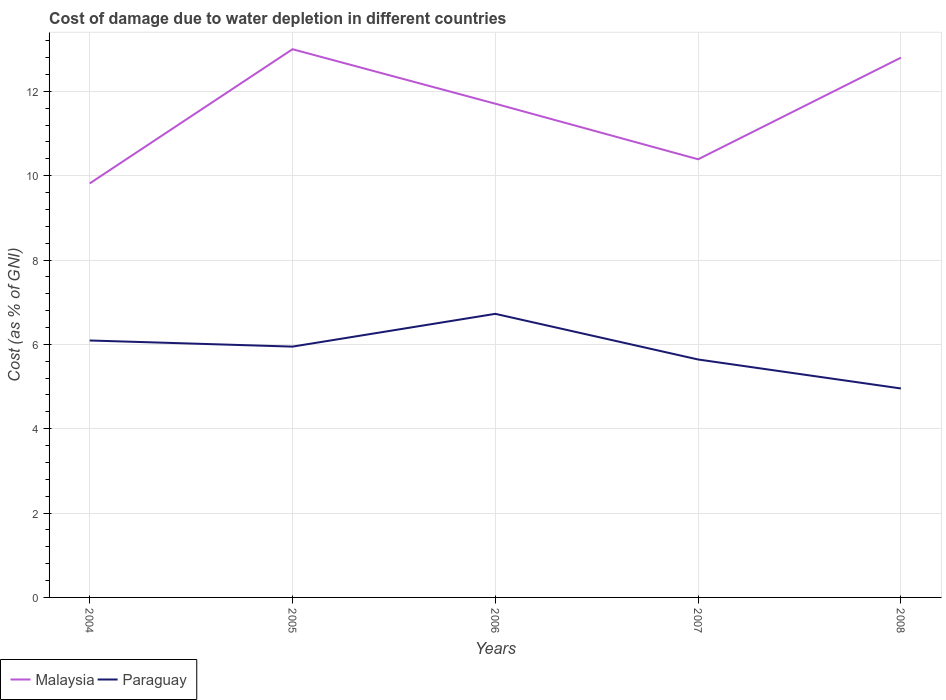Across all years, what is the maximum cost of damage caused due to water depletion in Malaysia?
Your response must be concise. 9.82. In which year was the cost of damage caused due to water depletion in Malaysia maximum?
Offer a terse response. 2004. What is the total cost of damage caused due to water depletion in Malaysia in the graph?
Give a very brief answer. -0.57. What is the difference between the highest and the second highest cost of damage caused due to water depletion in Malaysia?
Provide a succinct answer. 3.18. What is the difference between the highest and the lowest cost of damage caused due to water depletion in Paraguay?
Your answer should be compact. 3. Is the cost of damage caused due to water depletion in Malaysia strictly greater than the cost of damage caused due to water depletion in Paraguay over the years?
Ensure brevity in your answer.  No. How many lines are there?
Offer a very short reply. 2. How many years are there in the graph?
Your response must be concise. 5. What is the difference between two consecutive major ticks on the Y-axis?
Provide a short and direct response. 2. Are the values on the major ticks of Y-axis written in scientific E-notation?
Give a very brief answer. No. Where does the legend appear in the graph?
Keep it short and to the point. Bottom left. How many legend labels are there?
Provide a succinct answer. 2. How are the legend labels stacked?
Keep it short and to the point. Horizontal. What is the title of the graph?
Provide a succinct answer. Cost of damage due to water depletion in different countries. Does "Upper middle income" appear as one of the legend labels in the graph?
Your answer should be very brief. No. What is the label or title of the Y-axis?
Keep it short and to the point. Cost (as % of GNI). What is the Cost (as % of GNI) in Malaysia in 2004?
Offer a very short reply. 9.82. What is the Cost (as % of GNI) of Paraguay in 2004?
Provide a succinct answer. 6.09. What is the Cost (as % of GNI) of Malaysia in 2005?
Your answer should be compact. 13. What is the Cost (as % of GNI) of Paraguay in 2005?
Offer a terse response. 5.95. What is the Cost (as % of GNI) of Malaysia in 2006?
Offer a very short reply. 11.71. What is the Cost (as % of GNI) of Paraguay in 2006?
Provide a short and direct response. 6.72. What is the Cost (as % of GNI) of Malaysia in 2007?
Your answer should be very brief. 10.39. What is the Cost (as % of GNI) in Paraguay in 2007?
Provide a short and direct response. 5.64. What is the Cost (as % of GNI) of Malaysia in 2008?
Your answer should be compact. 12.8. What is the Cost (as % of GNI) in Paraguay in 2008?
Make the answer very short. 4.95. Across all years, what is the maximum Cost (as % of GNI) in Malaysia?
Offer a terse response. 13. Across all years, what is the maximum Cost (as % of GNI) of Paraguay?
Your response must be concise. 6.72. Across all years, what is the minimum Cost (as % of GNI) in Malaysia?
Your answer should be very brief. 9.82. Across all years, what is the minimum Cost (as % of GNI) of Paraguay?
Keep it short and to the point. 4.95. What is the total Cost (as % of GNI) of Malaysia in the graph?
Your answer should be compact. 57.71. What is the total Cost (as % of GNI) of Paraguay in the graph?
Your answer should be very brief. 29.36. What is the difference between the Cost (as % of GNI) in Malaysia in 2004 and that in 2005?
Your answer should be compact. -3.18. What is the difference between the Cost (as % of GNI) of Paraguay in 2004 and that in 2005?
Your response must be concise. 0.15. What is the difference between the Cost (as % of GNI) in Malaysia in 2004 and that in 2006?
Offer a terse response. -1.89. What is the difference between the Cost (as % of GNI) of Paraguay in 2004 and that in 2006?
Offer a very short reply. -0.63. What is the difference between the Cost (as % of GNI) of Malaysia in 2004 and that in 2007?
Keep it short and to the point. -0.57. What is the difference between the Cost (as % of GNI) in Paraguay in 2004 and that in 2007?
Make the answer very short. 0.45. What is the difference between the Cost (as % of GNI) of Malaysia in 2004 and that in 2008?
Keep it short and to the point. -2.98. What is the difference between the Cost (as % of GNI) in Paraguay in 2004 and that in 2008?
Your response must be concise. 1.14. What is the difference between the Cost (as % of GNI) in Malaysia in 2005 and that in 2006?
Provide a short and direct response. 1.29. What is the difference between the Cost (as % of GNI) in Paraguay in 2005 and that in 2006?
Offer a terse response. -0.78. What is the difference between the Cost (as % of GNI) of Malaysia in 2005 and that in 2007?
Ensure brevity in your answer.  2.61. What is the difference between the Cost (as % of GNI) in Paraguay in 2005 and that in 2007?
Give a very brief answer. 0.31. What is the difference between the Cost (as % of GNI) of Malaysia in 2005 and that in 2008?
Offer a very short reply. 0.2. What is the difference between the Cost (as % of GNI) in Malaysia in 2006 and that in 2007?
Keep it short and to the point. 1.32. What is the difference between the Cost (as % of GNI) in Paraguay in 2006 and that in 2007?
Give a very brief answer. 1.08. What is the difference between the Cost (as % of GNI) of Malaysia in 2006 and that in 2008?
Keep it short and to the point. -1.09. What is the difference between the Cost (as % of GNI) of Paraguay in 2006 and that in 2008?
Offer a very short reply. 1.77. What is the difference between the Cost (as % of GNI) in Malaysia in 2007 and that in 2008?
Make the answer very short. -2.41. What is the difference between the Cost (as % of GNI) of Paraguay in 2007 and that in 2008?
Give a very brief answer. 0.69. What is the difference between the Cost (as % of GNI) of Malaysia in 2004 and the Cost (as % of GNI) of Paraguay in 2005?
Make the answer very short. 3.87. What is the difference between the Cost (as % of GNI) in Malaysia in 2004 and the Cost (as % of GNI) in Paraguay in 2006?
Your response must be concise. 3.09. What is the difference between the Cost (as % of GNI) of Malaysia in 2004 and the Cost (as % of GNI) of Paraguay in 2007?
Your answer should be compact. 4.17. What is the difference between the Cost (as % of GNI) in Malaysia in 2004 and the Cost (as % of GNI) in Paraguay in 2008?
Offer a very short reply. 4.86. What is the difference between the Cost (as % of GNI) of Malaysia in 2005 and the Cost (as % of GNI) of Paraguay in 2006?
Offer a terse response. 6.27. What is the difference between the Cost (as % of GNI) of Malaysia in 2005 and the Cost (as % of GNI) of Paraguay in 2007?
Your answer should be compact. 7.36. What is the difference between the Cost (as % of GNI) of Malaysia in 2005 and the Cost (as % of GNI) of Paraguay in 2008?
Offer a terse response. 8.04. What is the difference between the Cost (as % of GNI) in Malaysia in 2006 and the Cost (as % of GNI) in Paraguay in 2007?
Provide a short and direct response. 6.06. What is the difference between the Cost (as % of GNI) of Malaysia in 2006 and the Cost (as % of GNI) of Paraguay in 2008?
Provide a succinct answer. 6.75. What is the difference between the Cost (as % of GNI) in Malaysia in 2007 and the Cost (as % of GNI) in Paraguay in 2008?
Your answer should be compact. 5.43. What is the average Cost (as % of GNI) in Malaysia per year?
Ensure brevity in your answer.  11.54. What is the average Cost (as % of GNI) in Paraguay per year?
Your answer should be compact. 5.87. In the year 2004, what is the difference between the Cost (as % of GNI) of Malaysia and Cost (as % of GNI) of Paraguay?
Your response must be concise. 3.72. In the year 2005, what is the difference between the Cost (as % of GNI) of Malaysia and Cost (as % of GNI) of Paraguay?
Give a very brief answer. 7.05. In the year 2006, what is the difference between the Cost (as % of GNI) of Malaysia and Cost (as % of GNI) of Paraguay?
Provide a succinct answer. 4.98. In the year 2007, what is the difference between the Cost (as % of GNI) of Malaysia and Cost (as % of GNI) of Paraguay?
Offer a terse response. 4.75. In the year 2008, what is the difference between the Cost (as % of GNI) of Malaysia and Cost (as % of GNI) of Paraguay?
Your response must be concise. 7.84. What is the ratio of the Cost (as % of GNI) in Malaysia in 2004 to that in 2005?
Your answer should be compact. 0.76. What is the ratio of the Cost (as % of GNI) in Paraguay in 2004 to that in 2005?
Offer a terse response. 1.02. What is the ratio of the Cost (as % of GNI) of Malaysia in 2004 to that in 2006?
Offer a very short reply. 0.84. What is the ratio of the Cost (as % of GNI) in Paraguay in 2004 to that in 2006?
Keep it short and to the point. 0.91. What is the ratio of the Cost (as % of GNI) of Malaysia in 2004 to that in 2007?
Your response must be concise. 0.94. What is the ratio of the Cost (as % of GNI) of Paraguay in 2004 to that in 2007?
Your response must be concise. 1.08. What is the ratio of the Cost (as % of GNI) of Malaysia in 2004 to that in 2008?
Offer a terse response. 0.77. What is the ratio of the Cost (as % of GNI) of Paraguay in 2004 to that in 2008?
Keep it short and to the point. 1.23. What is the ratio of the Cost (as % of GNI) in Malaysia in 2005 to that in 2006?
Provide a short and direct response. 1.11. What is the ratio of the Cost (as % of GNI) in Paraguay in 2005 to that in 2006?
Offer a very short reply. 0.88. What is the ratio of the Cost (as % of GNI) of Malaysia in 2005 to that in 2007?
Your answer should be very brief. 1.25. What is the ratio of the Cost (as % of GNI) in Paraguay in 2005 to that in 2007?
Keep it short and to the point. 1.05. What is the ratio of the Cost (as % of GNI) of Malaysia in 2005 to that in 2008?
Provide a succinct answer. 1.02. What is the ratio of the Cost (as % of GNI) in Paraguay in 2005 to that in 2008?
Offer a terse response. 1.2. What is the ratio of the Cost (as % of GNI) in Malaysia in 2006 to that in 2007?
Your answer should be compact. 1.13. What is the ratio of the Cost (as % of GNI) in Paraguay in 2006 to that in 2007?
Make the answer very short. 1.19. What is the ratio of the Cost (as % of GNI) in Malaysia in 2006 to that in 2008?
Your answer should be very brief. 0.91. What is the ratio of the Cost (as % of GNI) of Paraguay in 2006 to that in 2008?
Your answer should be very brief. 1.36. What is the ratio of the Cost (as % of GNI) in Malaysia in 2007 to that in 2008?
Keep it short and to the point. 0.81. What is the ratio of the Cost (as % of GNI) in Paraguay in 2007 to that in 2008?
Make the answer very short. 1.14. What is the difference between the highest and the second highest Cost (as % of GNI) of Malaysia?
Your response must be concise. 0.2. What is the difference between the highest and the second highest Cost (as % of GNI) of Paraguay?
Make the answer very short. 0.63. What is the difference between the highest and the lowest Cost (as % of GNI) of Malaysia?
Make the answer very short. 3.18. What is the difference between the highest and the lowest Cost (as % of GNI) in Paraguay?
Offer a very short reply. 1.77. 